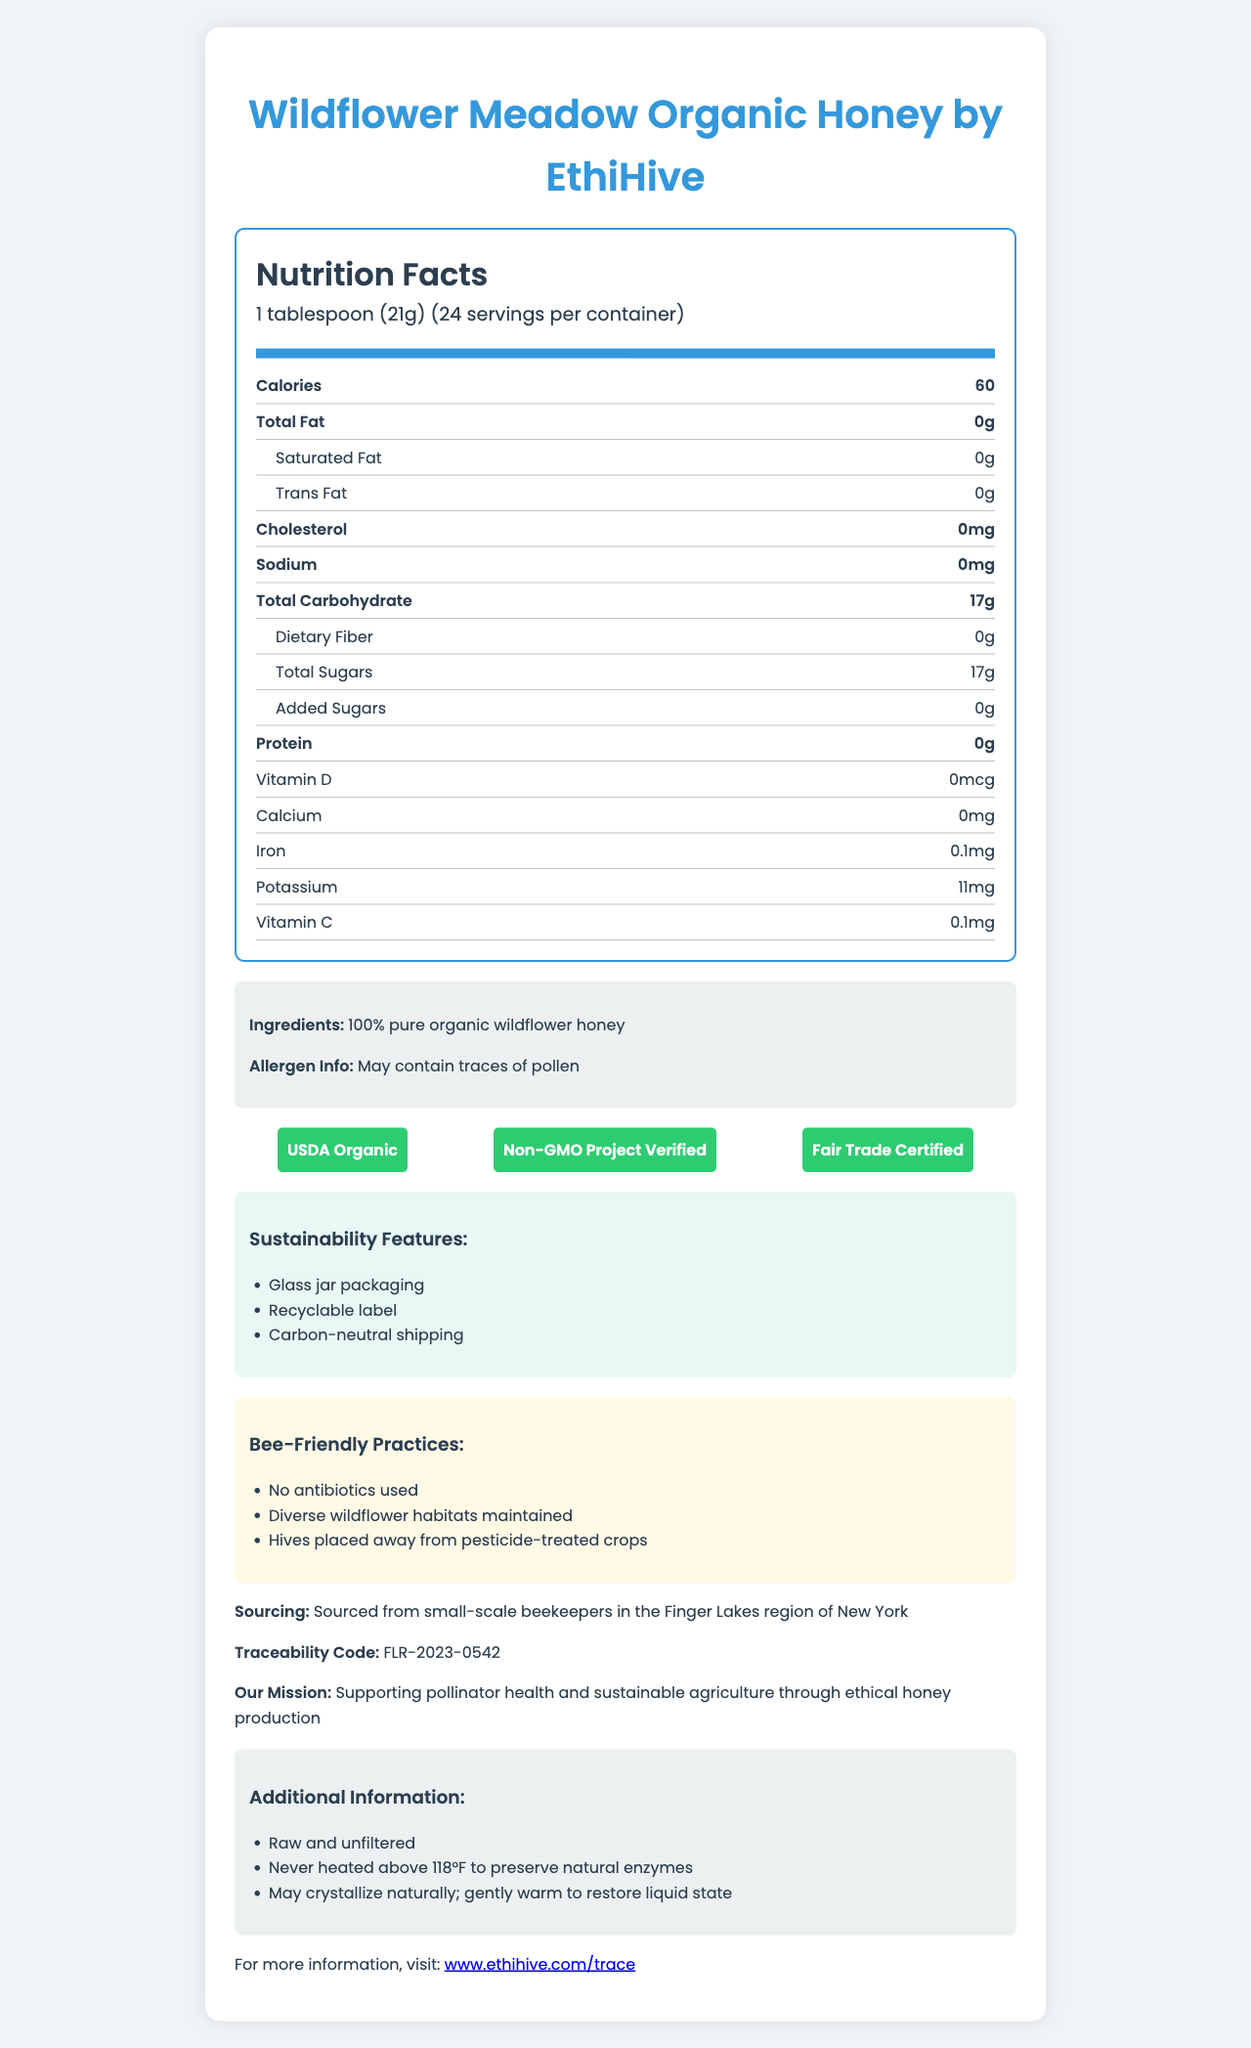what is the serving size? The serving size is specified in the nutrition facts section as 1 tablespoon (21g).
Answer: 1 tablespoon (21g) how many servings are there per container? The number of servings per container is listed as 24 in the nutrition facts section.
Answer: 24 how many calories are in one serving? The number of calories per serving is listed as 60 in the nutrition facts section.
Answer: 60 calories what is the total carbohydrate content per serving? The total carbohydrate content per serving is 17g, as listed in the nutrition facts section.
Answer: 17g does the honey contain any added sugars? The nutrition facts section indicates that there are 0g of added sugars.
Answer: no what certifications does the product have? A. USDA Organic B. Non-GMO Project Verified C. Fair Trade Certified D. All of the above The certifications section lists USDA Organic, Non-GMO Project Verified, and Fair Trade Certified.
Answer: D which of the following is not mentioned as a sustainability feature? 1. Biodegradable packaging 2. Glass jar packaging 3. Carbon-neutral shipping The sustainability features listed include glass jar packaging and carbon-neutral shipping, but not biodegradable packaging.
Answer: 1 is the honey raw and unfiltered? The additional information section mentions that the honey is raw and unfiltered.
Answer: yes does the honey contain any dietary fiber? The nutrition facts section shows that the dietary fiber content per serving is 0g.
Answer: no describe the main idea of the document. The document outlines key nutritional facts, emphasizes the ethical sourcing and sustainable practices implemented by the brand, and highlights the traceability and additional features of the product.
Answer: The document provides comprehensive details about Wildflower Meadow Organic Honey by EthiHive, including nutritional information, ingredients, certifications, sourcing, bee-friendly practices, sustainability features, traceability code, and additional product information. where can I find the traceability code for the honey? The traceability code is listed towards the end of the document as FLR-2023-0542.
Answer: FLR-2023-0542 are antibiotics used in the bee-friendly practices of this honey? The bee-friendly practices section specifically states that no antibiotics are used.
Answer: no what is the source region for the honey? The sourcing information indicates that the honey is sourced from small-scale beekeepers in the Finger Lakes region of New York.
Answer: Finger Lakes region of New York does the honey contain vitamin D? The nutrition facts section shows that the vitamin D content per serving is 0mcg.
Answer: no what is the brand mission? The company mission section outlines that the brand's mission is supporting pollinator health and sustainable agriculture through ethical honey production.
Answer: Supporting pollinator health and sustainable agriculture through ethical honey production what is the role of the recyclable label mentioned in the sustainability features? The document mentions a recyclable label as a sustainability feature but does not provide details on its specific role.
Answer: cannot be determined 